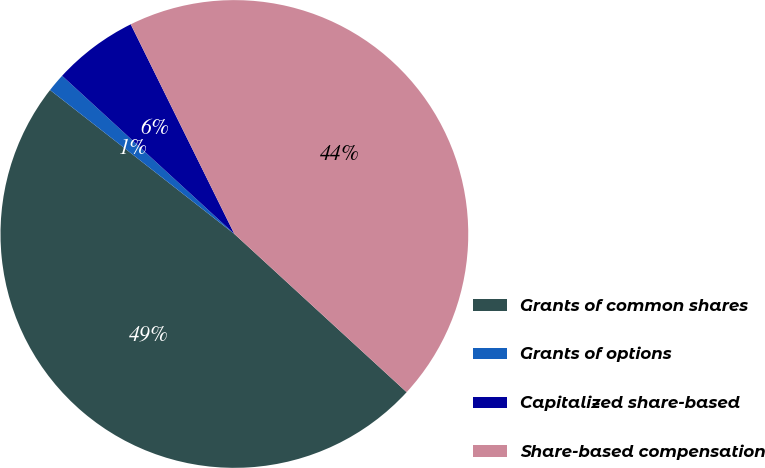<chart> <loc_0><loc_0><loc_500><loc_500><pie_chart><fcel>Grants of common shares<fcel>Grants of options<fcel>Capitalized share-based<fcel>Share-based compensation<nl><fcel>48.73%<fcel>1.27%<fcel>5.87%<fcel>44.13%<nl></chart> 